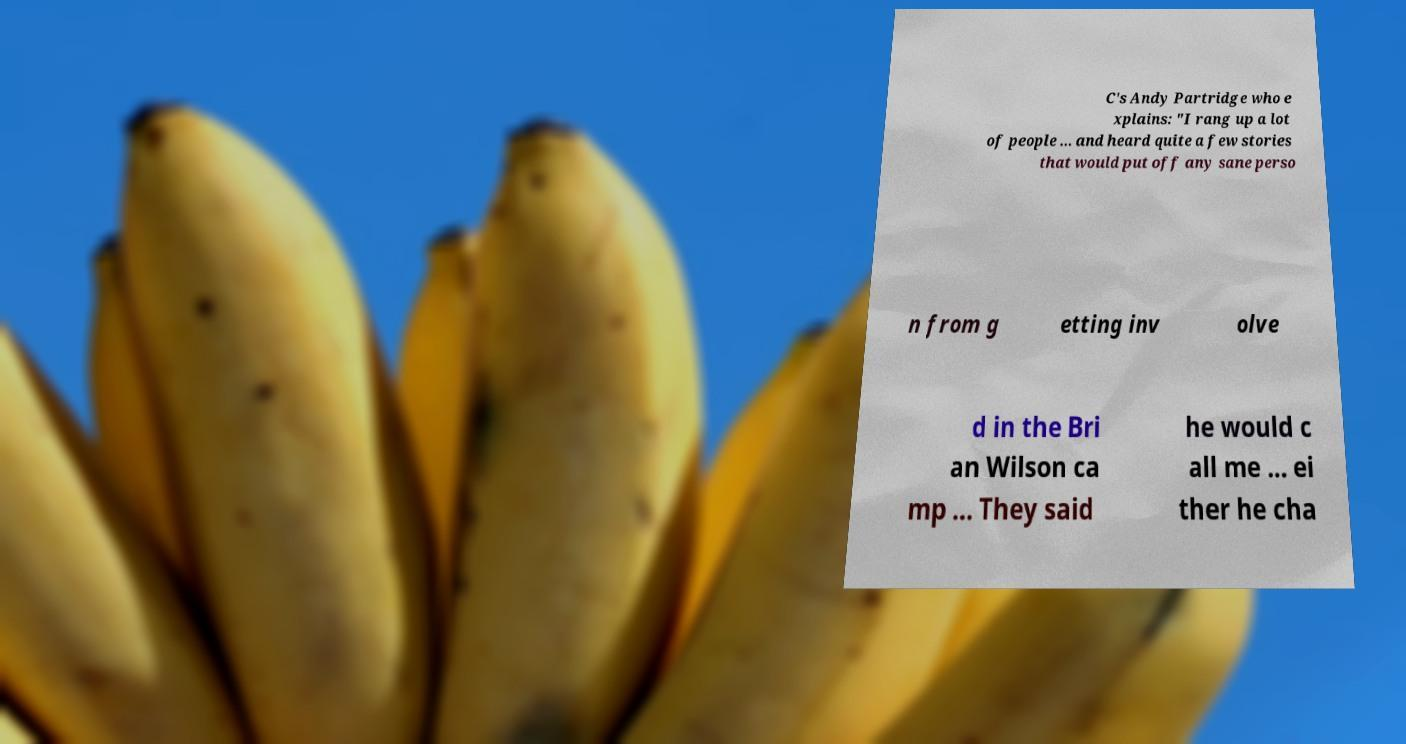What messages or text are displayed in this image? I need them in a readable, typed format. C's Andy Partridge who e xplains: "I rang up a lot of people ... and heard quite a few stories that would put off any sane perso n from g etting inv olve d in the Bri an Wilson ca mp ... They said he would c all me ... ei ther he cha 